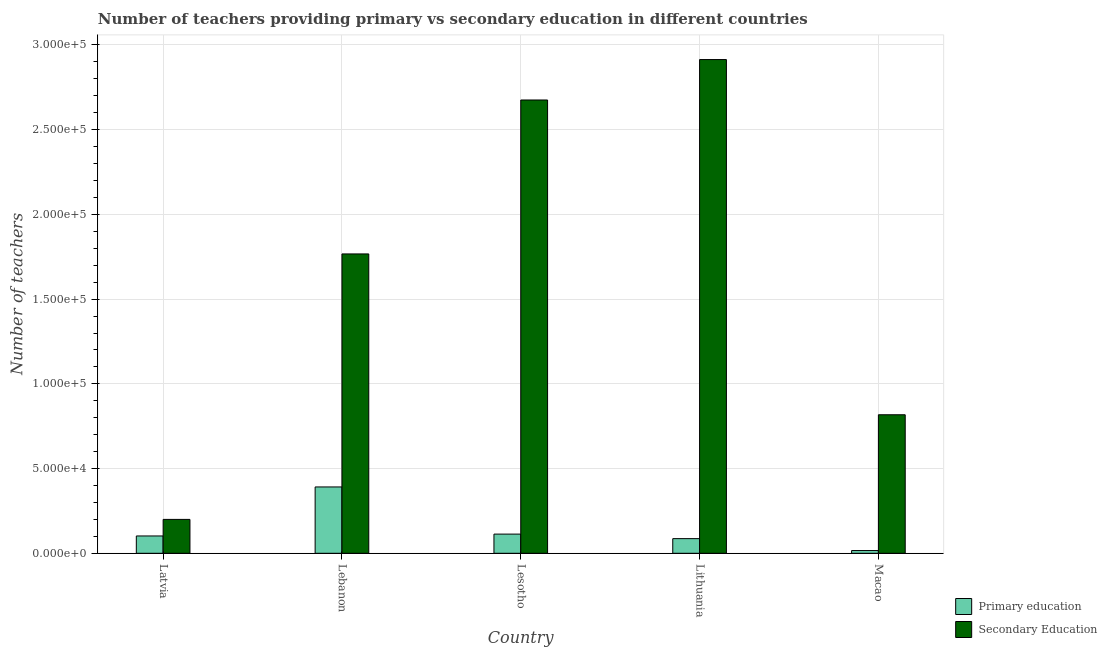How many different coloured bars are there?
Make the answer very short. 2. Are the number of bars on each tick of the X-axis equal?
Ensure brevity in your answer.  Yes. How many bars are there on the 3rd tick from the left?
Offer a very short reply. 2. How many bars are there on the 3rd tick from the right?
Make the answer very short. 2. What is the label of the 3rd group of bars from the left?
Keep it short and to the point. Lesotho. In how many cases, is the number of bars for a given country not equal to the number of legend labels?
Your answer should be very brief. 0. What is the number of primary teachers in Lebanon?
Your answer should be very brief. 3.91e+04. Across all countries, what is the maximum number of primary teachers?
Offer a very short reply. 3.91e+04. Across all countries, what is the minimum number of secondary teachers?
Make the answer very short. 2.00e+04. In which country was the number of primary teachers maximum?
Your response must be concise. Lebanon. In which country was the number of primary teachers minimum?
Provide a succinct answer. Macao. What is the total number of secondary teachers in the graph?
Provide a short and direct response. 8.37e+05. What is the difference between the number of secondary teachers in Latvia and that in Lesotho?
Give a very brief answer. -2.48e+05. What is the difference between the number of secondary teachers in Lesotho and the number of primary teachers in Latvia?
Offer a terse response. 2.57e+05. What is the average number of primary teachers per country?
Keep it short and to the point. 1.42e+04. What is the difference between the number of primary teachers and number of secondary teachers in Lebanon?
Your response must be concise. -1.38e+05. In how many countries, is the number of primary teachers greater than 210000 ?
Provide a short and direct response. 0. What is the ratio of the number of primary teachers in Latvia to that in Lithuania?
Your answer should be compact. 1.18. Is the number of primary teachers in Lebanon less than that in Lesotho?
Your answer should be compact. No. Is the difference between the number of secondary teachers in Latvia and Lesotho greater than the difference between the number of primary teachers in Latvia and Lesotho?
Your answer should be very brief. No. What is the difference between the highest and the second highest number of primary teachers?
Your response must be concise. 2.78e+04. What is the difference between the highest and the lowest number of primary teachers?
Provide a succinct answer. 3.75e+04. In how many countries, is the number of secondary teachers greater than the average number of secondary teachers taken over all countries?
Give a very brief answer. 3. Is the sum of the number of primary teachers in Lebanon and Lesotho greater than the maximum number of secondary teachers across all countries?
Make the answer very short. No. What does the 1st bar from the left in Latvia represents?
Your answer should be compact. Primary education. What does the 2nd bar from the right in Lithuania represents?
Offer a terse response. Primary education. How many bars are there?
Your answer should be very brief. 10. Are all the bars in the graph horizontal?
Provide a short and direct response. No. How many countries are there in the graph?
Provide a short and direct response. 5. What is the difference between two consecutive major ticks on the Y-axis?
Provide a succinct answer. 5.00e+04. Does the graph contain any zero values?
Your response must be concise. No. Does the graph contain grids?
Offer a very short reply. Yes. Where does the legend appear in the graph?
Offer a very short reply. Bottom right. What is the title of the graph?
Provide a succinct answer. Number of teachers providing primary vs secondary education in different countries. Does "Male" appear as one of the legend labels in the graph?
Offer a terse response. No. What is the label or title of the X-axis?
Offer a very short reply. Country. What is the label or title of the Y-axis?
Offer a terse response. Number of teachers. What is the Number of teachers in Primary education in Latvia?
Ensure brevity in your answer.  1.02e+04. What is the Number of teachers of Secondary Education in Latvia?
Give a very brief answer. 2.00e+04. What is the Number of teachers in Primary education in Lebanon?
Ensure brevity in your answer.  3.91e+04. What is the Number of teachers of Secondary Education in Lebanon?
Your answer should be very brief. 1.77e+05. What is the Number of teachers in Primary education in Lesotho?
Offer a terse response. 1.13e+04. What is the Number of teachers of Secondary Education in Lesotho?
Your answer should be compact. 2.68e+05. What is the Number of teachers in Primary education in Lithuania?
Offer a very short reply. 8642. What is the Number of teachers in Secondary Education in Lithuania?
Provide a short and direct response. 2.91e+05. What is the Number of teachers of Primary education in Macao?
Your response must be concise. 1622. What is the Number of teachers in Secondary Education in Macao?
Provide a succinct answer. 8.17e+04. Across all countries, what is the maximum Number of teachers of Primary education?
Make the answer very short. 3.91e+04. Across all countries, what is the maximum Number of teachers of Secondary Education?
Offer a terse response. 2.91e+05. Across all countries, what is the minimum Number of teachers in Primary education?
Your answer should be compact. 1622. Across all countries, what is the minimum Number of teachers of Secondary Education?
Provide a short and direct response. 2.00e+04. What is the total Number of teachers of Primary education in the graph?
Provide a short and direct response. 7.10e+04. What is the total Number of teachers of Secondary Education in the graph?
Your answer should be compact. 8.37e+05. What is the difference between the Number of teachers in Primary education in Latvia and that in Lebanon?
Provide a succinct answer. -2.89e+04. What is the difference between the Number of teachers in Secondary Education in Latvia and that in Lebanon?
Make the answer very short. -1.57e+05. What is the difference between the Number of teachers in Primary education in Latvia and that in Lesotho?
Your answer should be very brief. -1103. What is the difference between the Number of teachers of Secondary Education in Latvia and that in Lesotho?
Your answer should be compact. -2.48e+05. What is the difference between the Number of teachers in Primary education in Latvia and that in Lithuania?
Offer a very short reply. 1579. What is the difference between the Number of teachers in Secondary Education in Latvia and that in Lithuania?
Offer a very short reply. -2.71e+05. What is the difference between the Number of teachers in Primary education in Latvia and that in Macao?
Offer a very short reply. 8599. What is the difference between the Number of teachers of Secondary Education in Latvia and that in Macao?
Your response must be concise. -6.17e+04. What is the difference between the Number of teachers of Primary education in Lebanon and that in Lesotho?
Your response must be concise. 2.78e+04. What is the difference between the Number of teachers of Secondary Education in Lebanon and that in Lesotho?
Give a very brief answer. -9.09e+04. What is the difference between the Number of teachers in Primary education in Lebanon and that in Lithuania?
Offer a very short reply. 3.05e+04. What is the difference between the Number of teachers in Secondary Education in Lebanon and that in Lithuania?
Ensure brevity in your answer.  -1.15e+05. What is the difference between the Number of teachers of Primary education in Lebanon and that in Macao?
Your answer should be very brief. 3.75e+04. What is the difference between the Number of teachers of Secondary Education in Lebanon and that in Macao?
Your answer should be compact. 9.49e+04. What is the difference between the Number of teachers of Primary education in Lesotho and that in Lithuania?
Ensure brevity in your answer.  2682. What is the difference between the Number of teachers of Secondary Education in Lesotho and that in Lithuania?
Make the answer very short. -2.39e+04. What is the difference between the Number of teachers in Primary education in Lesotho and that in Macao?
Your answer should be compact. 9702. What is the difference between the Number of teachers of Secondary Education in Lesotho and that in Macao?
Make the answer very short. 1.86e+05. What is the difference between the Number of teachers in Primary education in Lithuania and that in Macao?
Offer a very short reply. 7020. What is the difference between the Number of teachers in Secondary Education in Lithuania and that in Macao?
Keep it short and to the point. 2.10e+05. What is the difference between the Number of teachers of Primary education in Latvia and the Number of teachers of Secondary Education in Lebanon?
Give a very brief answer. -1.66e+05. What is the difference between the Number of teachers in Primary education in Latvia and the Number of teachers in Secondary Education in Lesotho?
Your answer should be compact. -2.57e+05. What is the difference between the Number of teachers of Primary education in Latvia and the Number of teachers of Secondary Education in Lithuania?
Ensure brevity in your answer.  -2.81e+05. What is the difference between the Number of teachers of Primary education in Latvia and the Number of teachers of Secondary Education in Macao?
Provide a succinct answer. -7.15e+04. What is the difference between the Number of teachers of Primary education in Lebanon and the Number of teachers of Secondary Education in Lesotho?
Your answer should be compact. -2.28e+05. What is the difference between the Number of teachers of Primary education in Lebanon and the Number of teachers of Secondary Education in Lithuania?
Provide a short and direct response. -2.52e+05. What is the difference between the Number of teachers in Primary education in Lebanon and the Number of teachers in Secondary Education in Macao?
Keep it short and to the point. -4.26e+04. What is the difference between the Number of teachers of Primary education in Lesotho and the Number of teachers of Secondary Education in Lithuania?
Provide a succinct answer. -2.80e+05. What is the difference between the Number of teachers in Primary education in Lesotho and the Number of teachers in Secondary Education in Macao?
Ensure brevity in your answer.  -7.04e+04. What is the difference between the Number of teachers of Primary education in Lithuania and the Number of teachers of Secondary Education in Macao?
Keep it short and to the point. -7.31e+04. What is the average Number of teachers of Primary education per country?
Make the answer very short. 1.42e+04. What is the average Number of teachers in Secondary Education per country?
Your answer should be very brief. 1.67e+05. What is the difference between the Number of teachers in Primary education and Number of teachers in Secondary Education in Latvia?
Offer a terse response. -9780. What is the difference between the Number of teachers in Primary education and Number of teachers in Secondary Education in Lebanon?
Provide a succinct answer. -1.38e+05. What is the difference between the Number of teachers in Primary education and Number of teachers in Secondary Education in Lesotho?
Make the answer very short. -2.56e+05. What is the difference between the Number of teachers in Primary education and Number of teachers in Secondary Education in Lithuania?
Your answer should be very brief. -2.83e+05. What is the difference between the Number of teachers in Primary education and Number of teachers in Secondary Education in Macao?
Your answer should be very brief. -8.01e+04. What is the ratio of the Number of teachers of Primary education in Latvia to that in Lebanon?
Provide a short and direct response. 0.26. What is the ratio of the Number of teachers in Secondary Education in Latvia to that in Lebanon?
Keep it short and to the point. 0.11. What is the ratio of the Number of teachers of Primary education in Latvia to that in Lesotho?
Offer a terse response. 0.9. What is the ratio of the Number of teachers in Secondary Education in Latvia to that in Lesotho?
Provide a succinct answer. 0.07. What is the ratio of the Number of teachers in Primary education in Latvia to that in Lithuania?
Ensure brevity in your answer.  1.18. What is the ratio of the Number of teachers of Secondary Education in Latvia to that in Lithuania?
Provide a succinct answer. 0.07. What is the ratio of the Number of teachers of Primary education in Latvia to that in Macao?
Make the answer very short. 6.3. What is the ratio of the Number of teachers of Secondary Education in Latvia to that in Macao?
Ensure brevity in your answer.  0.24. What is the ratio of the Number of teachers of Primary education in Lebanon to that in Lesotho?
Provide a short and direct response. 3.46. What is the ratio of the Number of teachers of Secondary Education in Lebanon to that in Lesotho?
Give a very brief answer. 0.66. What is the ratio of the Number of teachers of Primary education in Lebanon to that in Lithuania?
Your answer should be very brief. 4.53. What is the ratio of the Number of teachers of Secondary Education in Lebanon to that in Lithuania?
Keep it short and to the point. 0.61. What is the ratio of the Number of teachers in Primary education in Lebanon to that in Macao?
Your response must be concise. 24.14. What is the ratio of the Number of teachers of Secondary Education in Lebanon to that in Macao?
Offer a terse response. 2.16. What is the ratio of the Number of teachers of Primary education in Lesotho to that in Lithuania?
Offer a terse response. 1.31. What is the ratio of the Number of teachers of Secondary Education in Lesotho to that in Lithuania?
Your answer should be compact. 0.92. What is the ratio of the Number of teachers in Primary education in Lesotho to that in Macao?
Make the answer very short. 6.98. What is the ratio of the Number of teachers in Secondary Education in Lesotho to that in Macao?
Ensure brevity in your answer.  3.27. What is the ratio of the Number of teachers in Primary education in Lithuania to that in Macao?
Keep it short and to the point. 5.33. What is the ratio of the Number of teachers in Secondary Education in Lithuania to that in Macao?
Your answer should be very brief. 3.56. What is the difference between the highest and the second highest Number of teachers in Primary education?
Keep it short and to the point. 2.78e+04. What is the difference between the highest and the second highest Number of teachers of Secondary Education?
Offer a very short reply. 2.39e+04. What is the difference between the highest and the lowest Number of teachers in Primary education?
Provide a short and direct response. 3.75e+04. What is the difference between the highest and the lowest Number of teachers of Secondary Education?
Make the answer very short. 2.71e+05. 